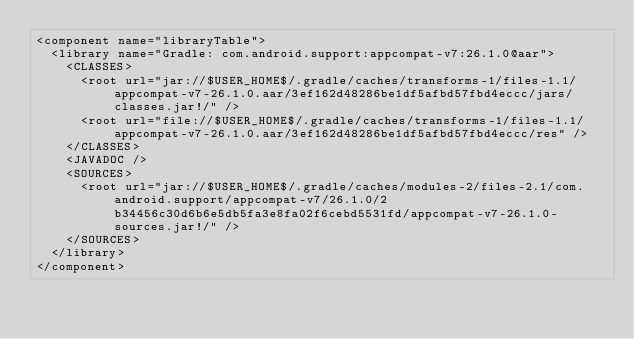<code> <loc_0><loc_0><loc_500><loc_500><_XML_><component name="libraryTable">
  <library name="Gradle: com.android.support:appcompat-v7:26.1.0@aar">
    <CLASSES>
      <root url="jar://$USER_HOME$/.gradle/caches/transforms-1/files-1.1/appcompat-v7-26.1.0.aar/3ef162d48286be1df5afbd57fbd4eccc/jars/classes.jar!/" />
      <root url="file://$USER_HOME$/.gradle/caches/transforms-1/files-1.1/appcompat-v7-26.1.0.aar/3ef162d48286be1df5afbd57fbd4eccc/res" />
    </CLASSES>
    <JAVADOC />
    <SOURCES>
      <root url="jar://$USER_HOME$/.gradle/caches/modules-2/files-2.1/com.android.support/appcompat-v7/26.1.0/2b34456c30d6b6e5db5fa3e8fa02f6cebd5531fd/appcompat-v7-26.1.0-sources.jar!/" />
    </SOURCES>
  </library>
</component></code> 